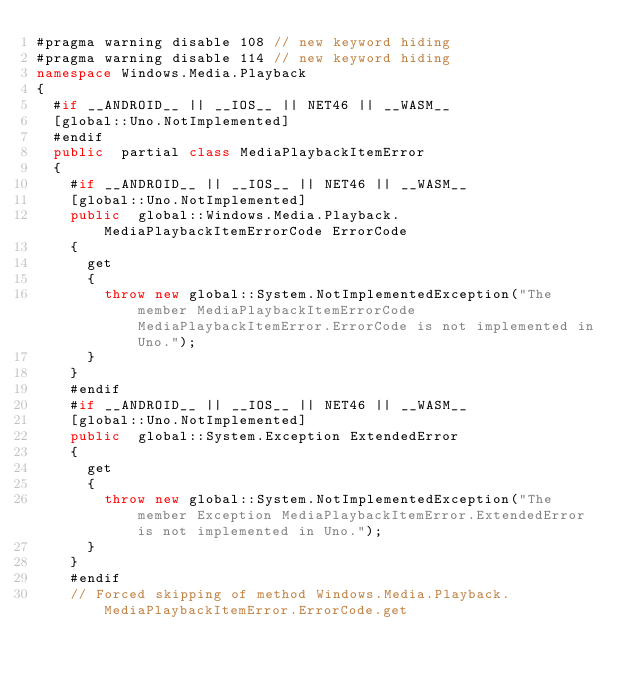<code> <loc_0><loc_0><loc_500><loc_500><_C#_>#pragma warning disable 108 // new keyword hiding
#pragma warning disable 114 // new keyword hiding
namespace Windows.Media.Playback
{
	#if __ANDROID__ || __IOS__ || NET46 || __WASM__
	[global::Uno.NotImplemented]
	#endif
	public  partial class MediaPlaybackItemError 
	{
		#if __ANDROID__ || __IOS__ || NET46 || __WASM__
		[global::Uno.NotImplemented]
		public  global::Windows.Media.Playback.MediaPlaybackItemErrorCode ErrorCode
		{
			get
			{
				throw new global::System.NotImplementedException("The member MediaPlaybackItemErrorCode MediaPlaybackItemError.ErrorCode is not implemented in Uno.");
			}
		}
		#endif
		#if __ANDROID__ || __IOS__ || NET46 || __WASM__
		[global::Uno.NotImplemented]
		public  global::System.Exception ExtendedError
		{
			get
			{
				throw new global::System.NotImplementedException("The member Exception MediaPlaybackItemError.ExtendedError is not implemented in Uno.");
			}
		}
		#endif
		// Forced skipping of method Windows.Media.Playback.MediaPlaybackItemError.ErrorCode.get</code> 